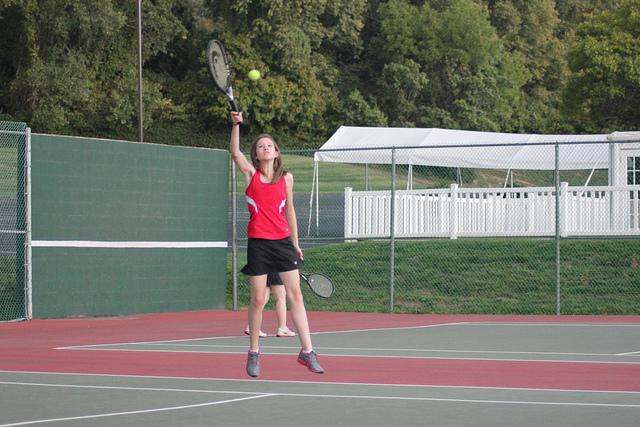What color is the woman's skirt?
Give a very brief answer. Black. How many rackets are there?
Concise answer only. 2. What is the lady wearing on her face?
Answer briefly. Nothing. What color is the girl's shirt?
Answer briefly. Red. What color is the fence?
Be succinct. Green. 